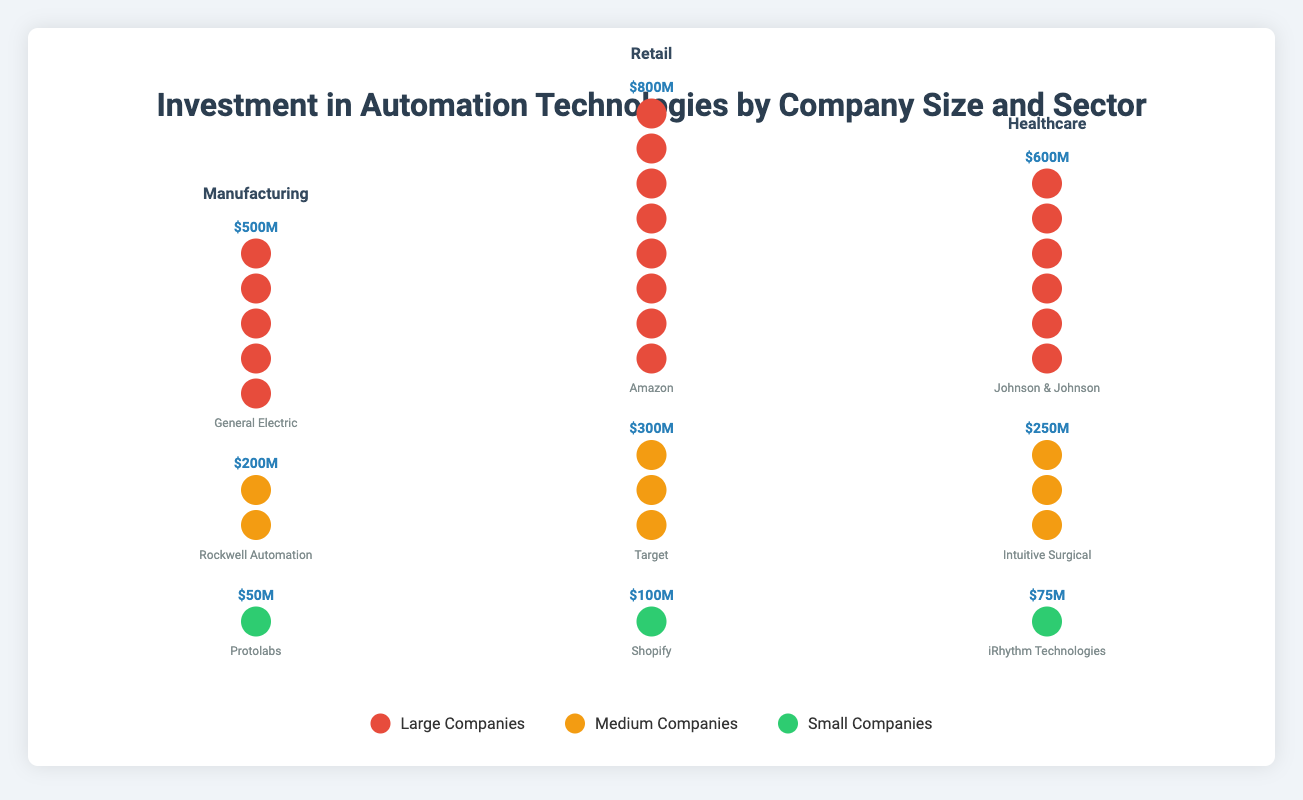What is the total investment in automation by Protolabs? Protolabs is a small company in the Manufacturing sector, and the investment value is displayed as $50M in the Isotype Plot.
Answer: $50M Which sector has the highest total investment from large companies? The plot shows the investment amounts for each large company in each sector: Manufacturing (General Electric: $500M), Retail (Amazon: $800M), Healthcare (Johnson & Johnson: $600M). The highest total investment is in the Retail sector with Amazon's $800M.
Answer: Retail How much more does Amazon invest in automation compared to Target? Amazon's investment is $800M while Target's investment is $300M. The difference is $800M - $300M = $500M.
Answer: $500M What is the combined investment in automation technologies by medium-sized companies across all sectors? The medium-sized companies and their investments are: Rockwell Automation ($200M), Target ($300M), Intuitive Surgical ($250M). The combined investment is $200M + $300M + $250M = $750M.
Answer: $750M Which small company has the second-highest investment in automation? The small companies and their investments are: Protolabs ($50M), Shopify ($100M), iRhythm Technologies ($75M). The second-highest investment is by iRhythm Technologies with $75M.
Answer: iRhythm Technologies In which sector do small companies invest the least in automation? From the Isotype plot, the investments by small companies are: Manufacturing (Protolabs: $50M), Retail (Shopify: $100M), Healthcare (iRhythm Technologies: $75M). The least investment is in the Manufacturing sector with $50M by Protolabs.
Answer: Manufacturing Compare the total investments in automation technologies between the Manufacturing and Healthcare sectors. Which one is greater and by how much? In Manufacturing: General Electric ($500M) + Rockwell Automation ($200M) + Protolabs ($50M) = $750M. In Healthcare: Johnson & Johnson ($600M) + Intuitive Surgical ($250M) + iRhythm Technologies ($75M) = $925M. Healthcare leads by $925M - $750M = $175M.
Answer: Healthcare, $175M What is the total number of robot icons representing the investments for each sector? Each $100M investment corresponds to one robot icon. Counting the robot icons: Manufacturing (9 icons), Retail (12 icons), Healthcare (10 icons).
Answer: Manufacturing: 9, Retail: 12, Healthcare: 10 